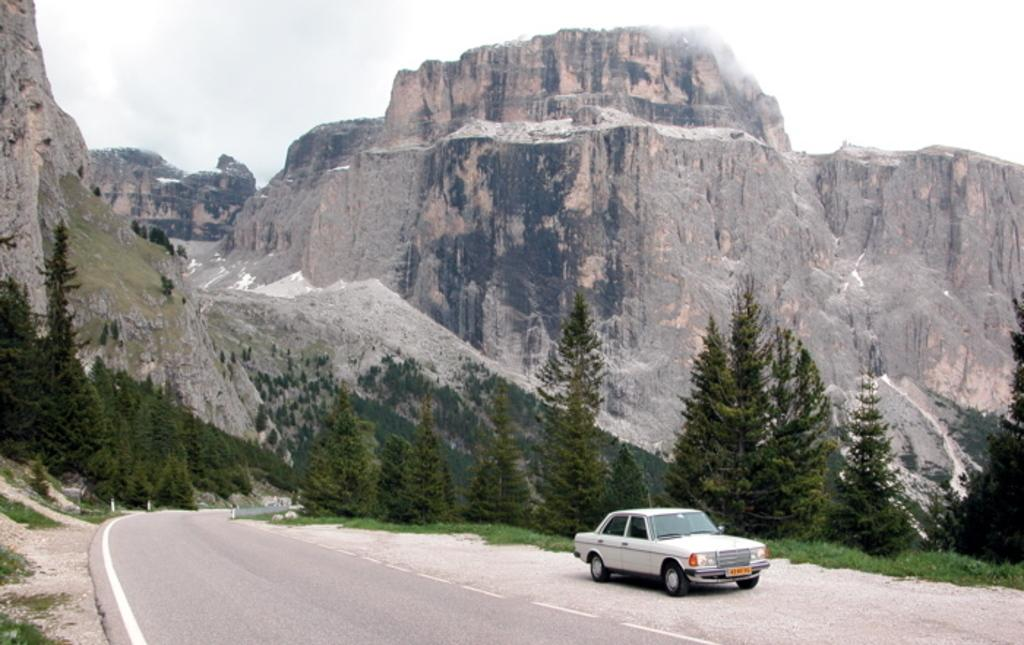What is the main feature of the image? There is a road in the image. What can be seen traveling on the road? There is a car in the image. What type of natural environment is depicted in the image? There are many trees and hills in the image. What part of the natural environment is visible in the image? The sky is visible in the image. What type of beef can be seen hanging from the trees in the image? There is no beef present in the image; it features a road, a car, trees, hills, and the sky. 